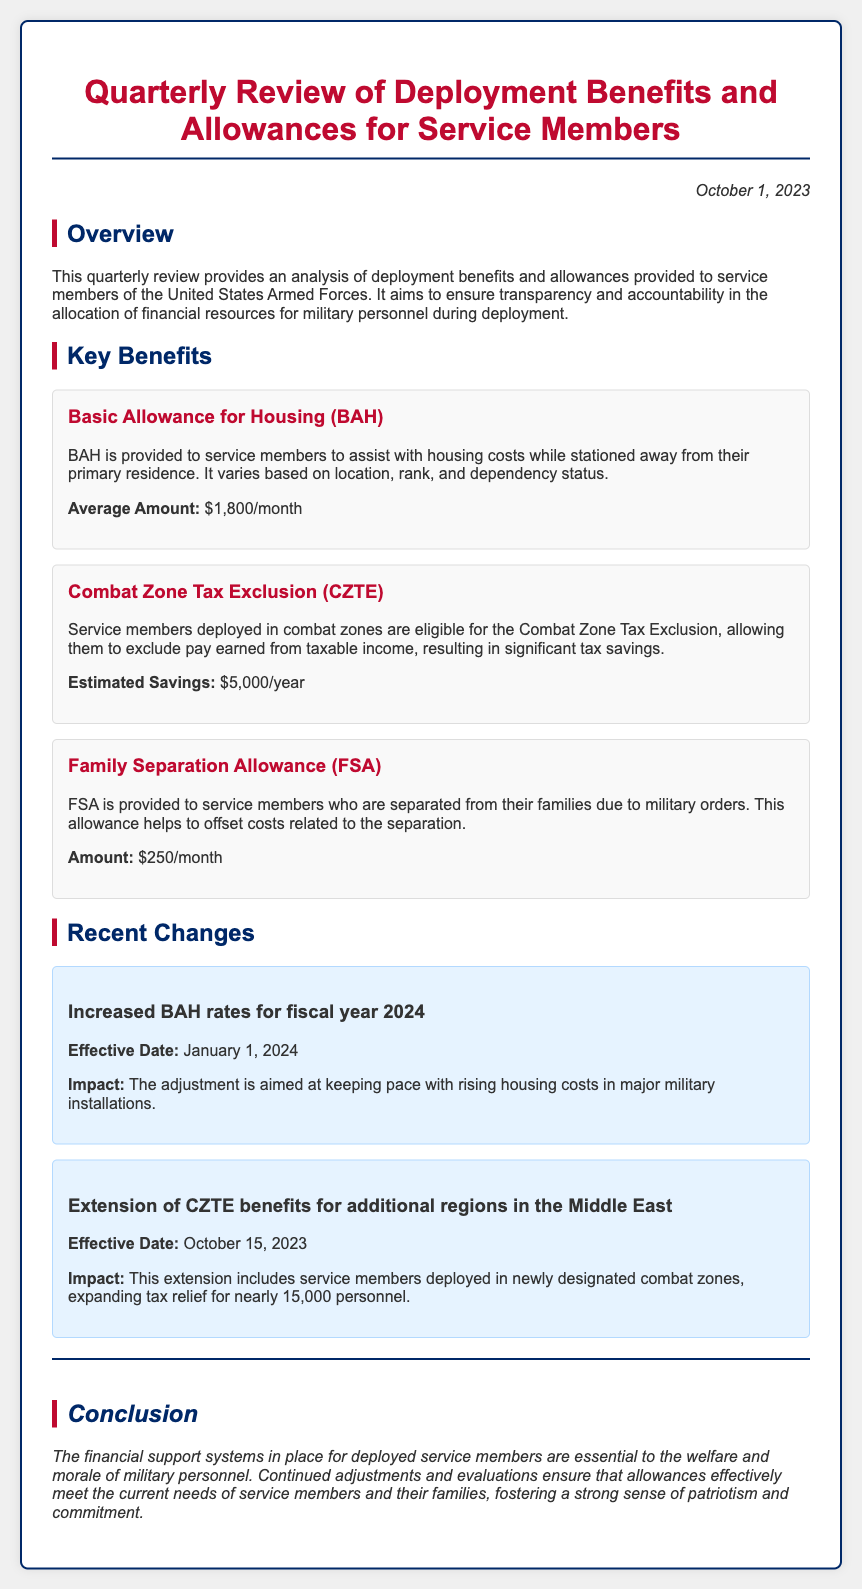What is the average amount for Basic Allowance for Housing? The average amount for Basic Allowance for Housing is stated in the document as $1,800/month.
Answer: $1,800/month What is the estimated savings from the Combat Zone Tax Exclusion? The document specifies the estimated savings from the Combat Zone Tax Exclusion as $5,000/year.
Answer: $5,000/year How much is the Family Separation Allowance? The Family Separation Allowance amount mentioned in the document is $250/month.
Answer: $250/month When will the increased BAH rates take effect? The effective date for the increased BAH rates is noted in the document as January 1, 2024.
Answer: January 1, 2024 What is the impact of the extension of CZTE benefits? The impact of extending CZTE benefits is that it expands tax relief for nearly 15,000 personnel.
Answer: Nearly 15,000 personnel What is the purpose of this quarterly review? The purpose of the quarterly review is to ensure transparency and accountability in the allocation of financial resources for military personnel during deployment.
Answer: Ensure transparency and accountability How does the recent change in BAH rates help service members? The document states that the adjustment is aimed at keeping pace with rising housing costs in major military installations.
Answer: Keeping pace with rising housing costs What allows service members to exclude pay from taxable income? The document indicates that the Combat Zone Tax Exclusion allows service members to exclude pay earned from taxable income.
Answer: Combat Zone Tax Exclusion What is the main conclusion of the review? The main conclusion is that financial support systems are essential to the welfare and morale of military personnel.
Answer: Essential to welfare and morale 